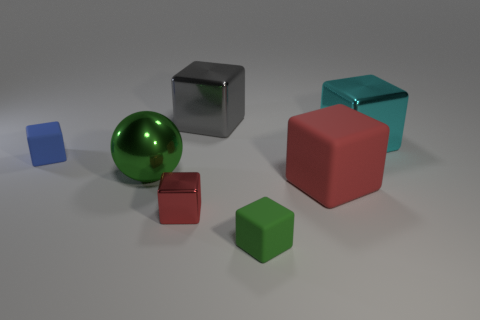Subtract all red blocks. How many blocks are left? 4 Subtract 4 blocks. How many blocks are left? 2 Subtract all small blue rubber blocks. How many blocks are left? 5 Subtract all green blocks. Subtract all red cylinders. How many blocks are left? 5 Add 2 green balls. How many objects exist? 9 Subtract all cubes. How many objects are left? 1 Add 6 large metal cubes. How many large metal cubes are left? 8 Add 5 big metal balls. How many big metal balls exist? 6 Subtract 0 green cylinders. How many objects are left? 7 Subtract all cyan metal things. Subtract all red rubber cubes. How many objects are left? 5 